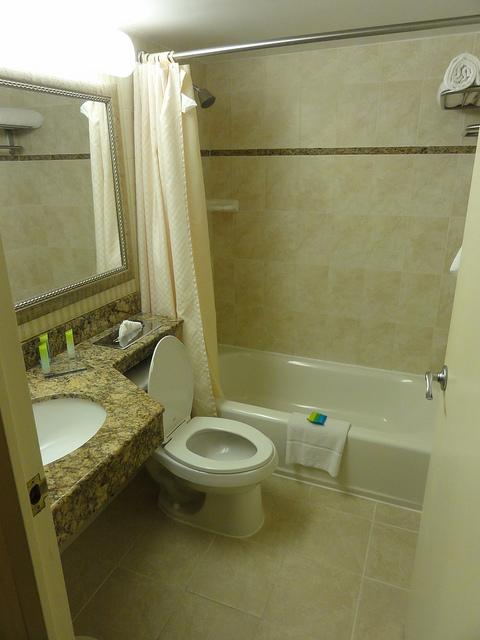How many yellow caps?
Short answer required. 3. Is there a tissue dispenser built in to the countertop?
Keep it brief. Yes. Does the vanity have drawers?
Concise answer only. No. Is this a standard American restroom?
Concise answer only. Yes. What is the color of the towel on the tub?
Answer briefly. White. What color is the seat?
Answer briefly. White. Can you cook food in this room?
Concise answer only. No. Are the curtains brown?
Quick response, please. No. Is this a public restroom?
Keep it brief. No. Is the grout clean?
Keep it brief. Yes. 